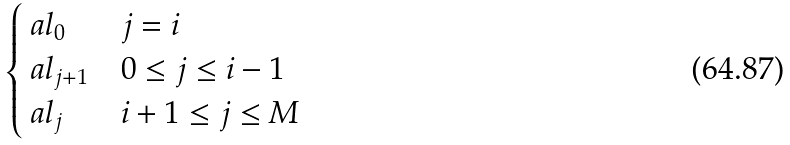Convert formula to latex. <formula><loc_0><loc_0><loc_500><loc_500>\begin{cases} \ a l _ { 0 } & j = i \\ \ a l _ { j + 1 } & 0 \leq j \leq i - 1 \\ \ a l _ { j } & i + 1 \leq j \leq M \end{cases}</formula> 